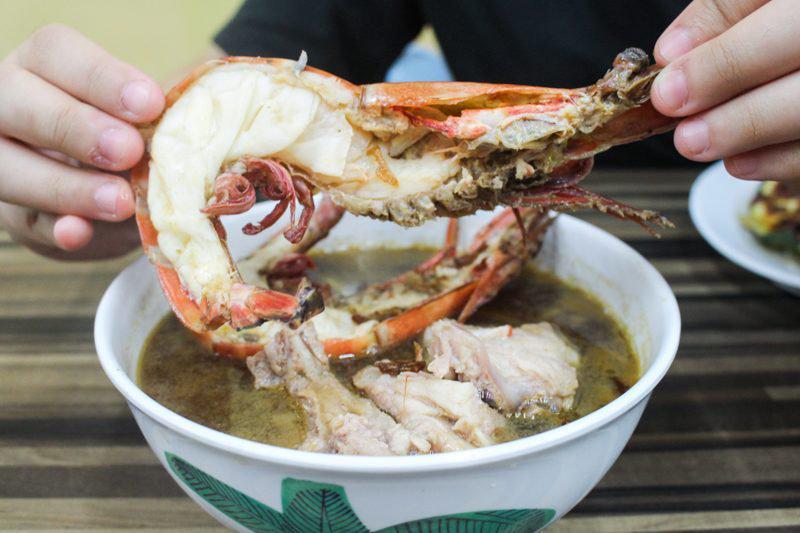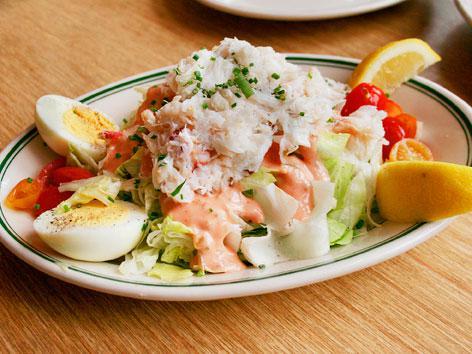The first image is the image on the left, the second image is the image on the right. Examine the images to the left and right. Is the description "The crab in one of the dishes sits in a bowl of liquid." accurate? Answer yes or no. Yes. The first image is the image on the left, the second image is the image on the right. For the images displayed, is the sentence "One of the dishes is a whole crab." factually correct? Answer yes or no. Yes. 